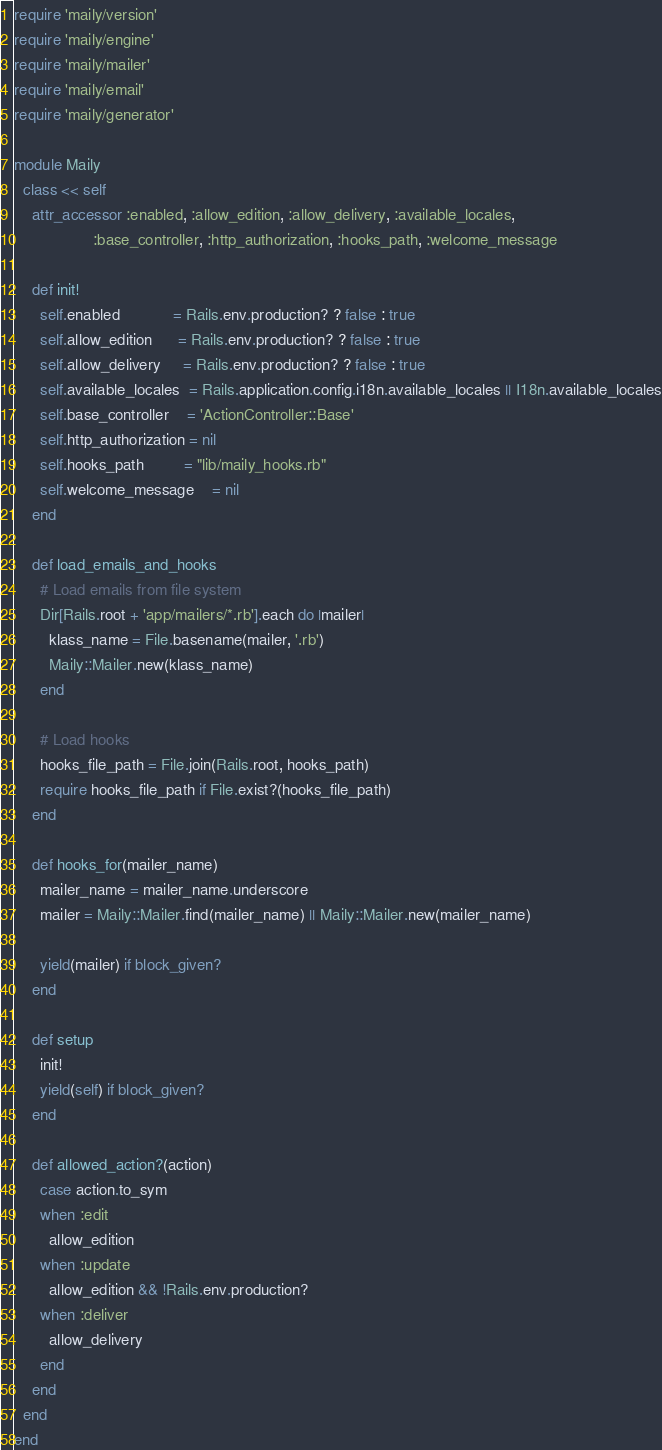<code> <loc_0><loc_0><loc_500><loc_500><_Ruby_>require 'maily/version'
require 'maily/engine'
require 'maily/mailer'
require 'maily/email'
require 'maily/generator'

module Maily
  class << self
    attr_accessor :enabled, :allow_edition, :allow_delivery, :available_locales,
                  :base_controller, :http_authorization, :hooks_path, :welcome_message

    def init!
      self.enabled            = Rails.env.production? ? false : true
      self.allow_edition      = Rails.env.production? ? false : true
      self.allow_delivery     = Rails.env.production? ? false : true
      self.available_locales  = Rails.application.config.i18n.available_locales || I18n.available_locales
      self.base_controller    = 'ActionController::Base'
      self.http_authorization = nil
      self.hooks_path         = "lib/maily_hooks.rb"
      self.welcome_message    = nil
    end

    def load_emails_and_hooks
      # Load emails from file system
      Dir[Rails.root + 'app/mailers/*.rb'].each do |mailer|
        klass_name = File.basename(mailer, '.rb')
        Maily::Mailer.new(klass_name)
      end

      # Load hooks
      hooks_file_path = File.join(Rails.root, hooks_path)
      require hooks_file_path if File.exist?(hooks_file_path)
    end

    def hooks_for(mailer_name)
      mailer_name = mailer_name.underscore
      mailer = Maily::Mailer.find(mailer_name) || Maily::Mailer.new(mailer_name)

      yield(mailer) if block_given?
    end

    def setup
      init!
      yield(self) if block_given?
    end

    def allowed_action?(action)
      case action.to_sym
      when :edit
        allow_edition
      when :update
        allow_edition && !Rails.env.production?
      when :deliver
        allow_delivery
      end
    end
  end
end
</code> 